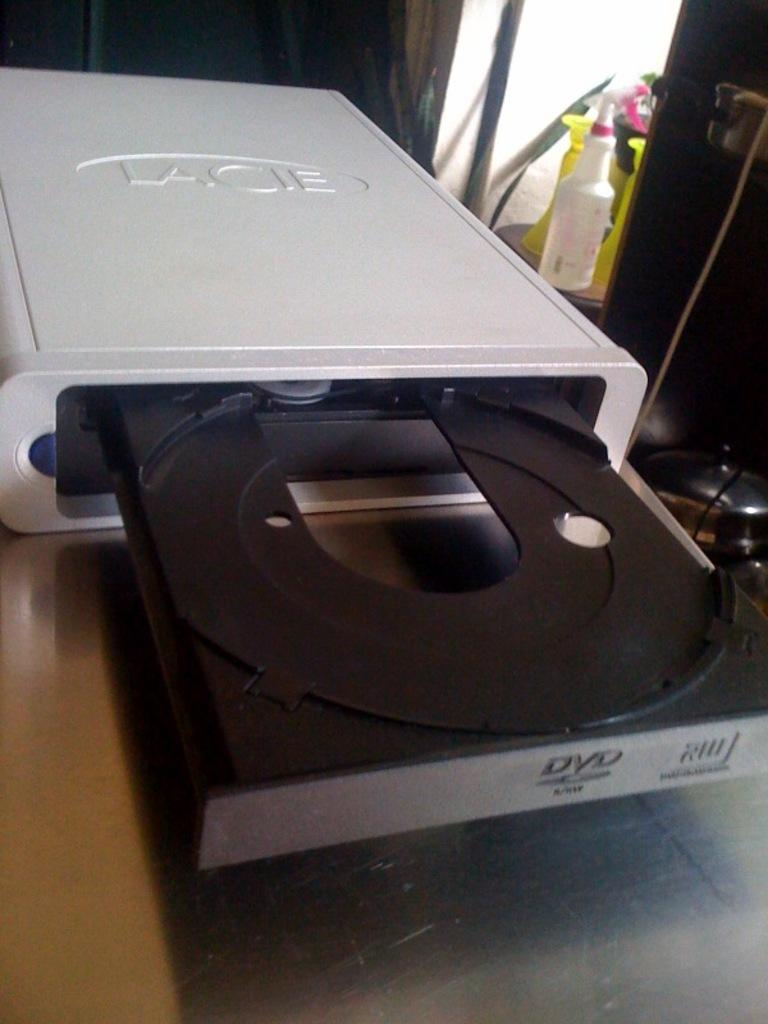<image>
Give a short and clear explanation of the subsequent image. An open Lacie CD tray that can read DVDs 